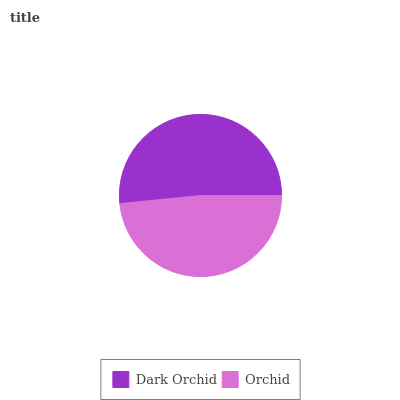Is Orchid the minimum?
Answer yes or no. Yes. Is Dark Orchid the maximum?
Answer yes or no. Yes. Is Orchid the maximum?
Answer yes or no. No. Is Dark Orchid greater than Orchid?
Answer yes or no. Yes. Is Orchid less than Dark Orchid?
Answer yes or no. Yes. Is Orchid greater than Dark Orchid?
Answer yes or no. No. Is Dark Orchid less than Orchid?
Answer yes or no. No. Is Dark Orchid the high median?
Answer yes or no. Yes. Is Orchid the low median?
Answer yes or no. Yes. Is Orchid the high median?
Answer yes or no. No. Is Dark Orchid the low median?
Answer yes or no. No. 